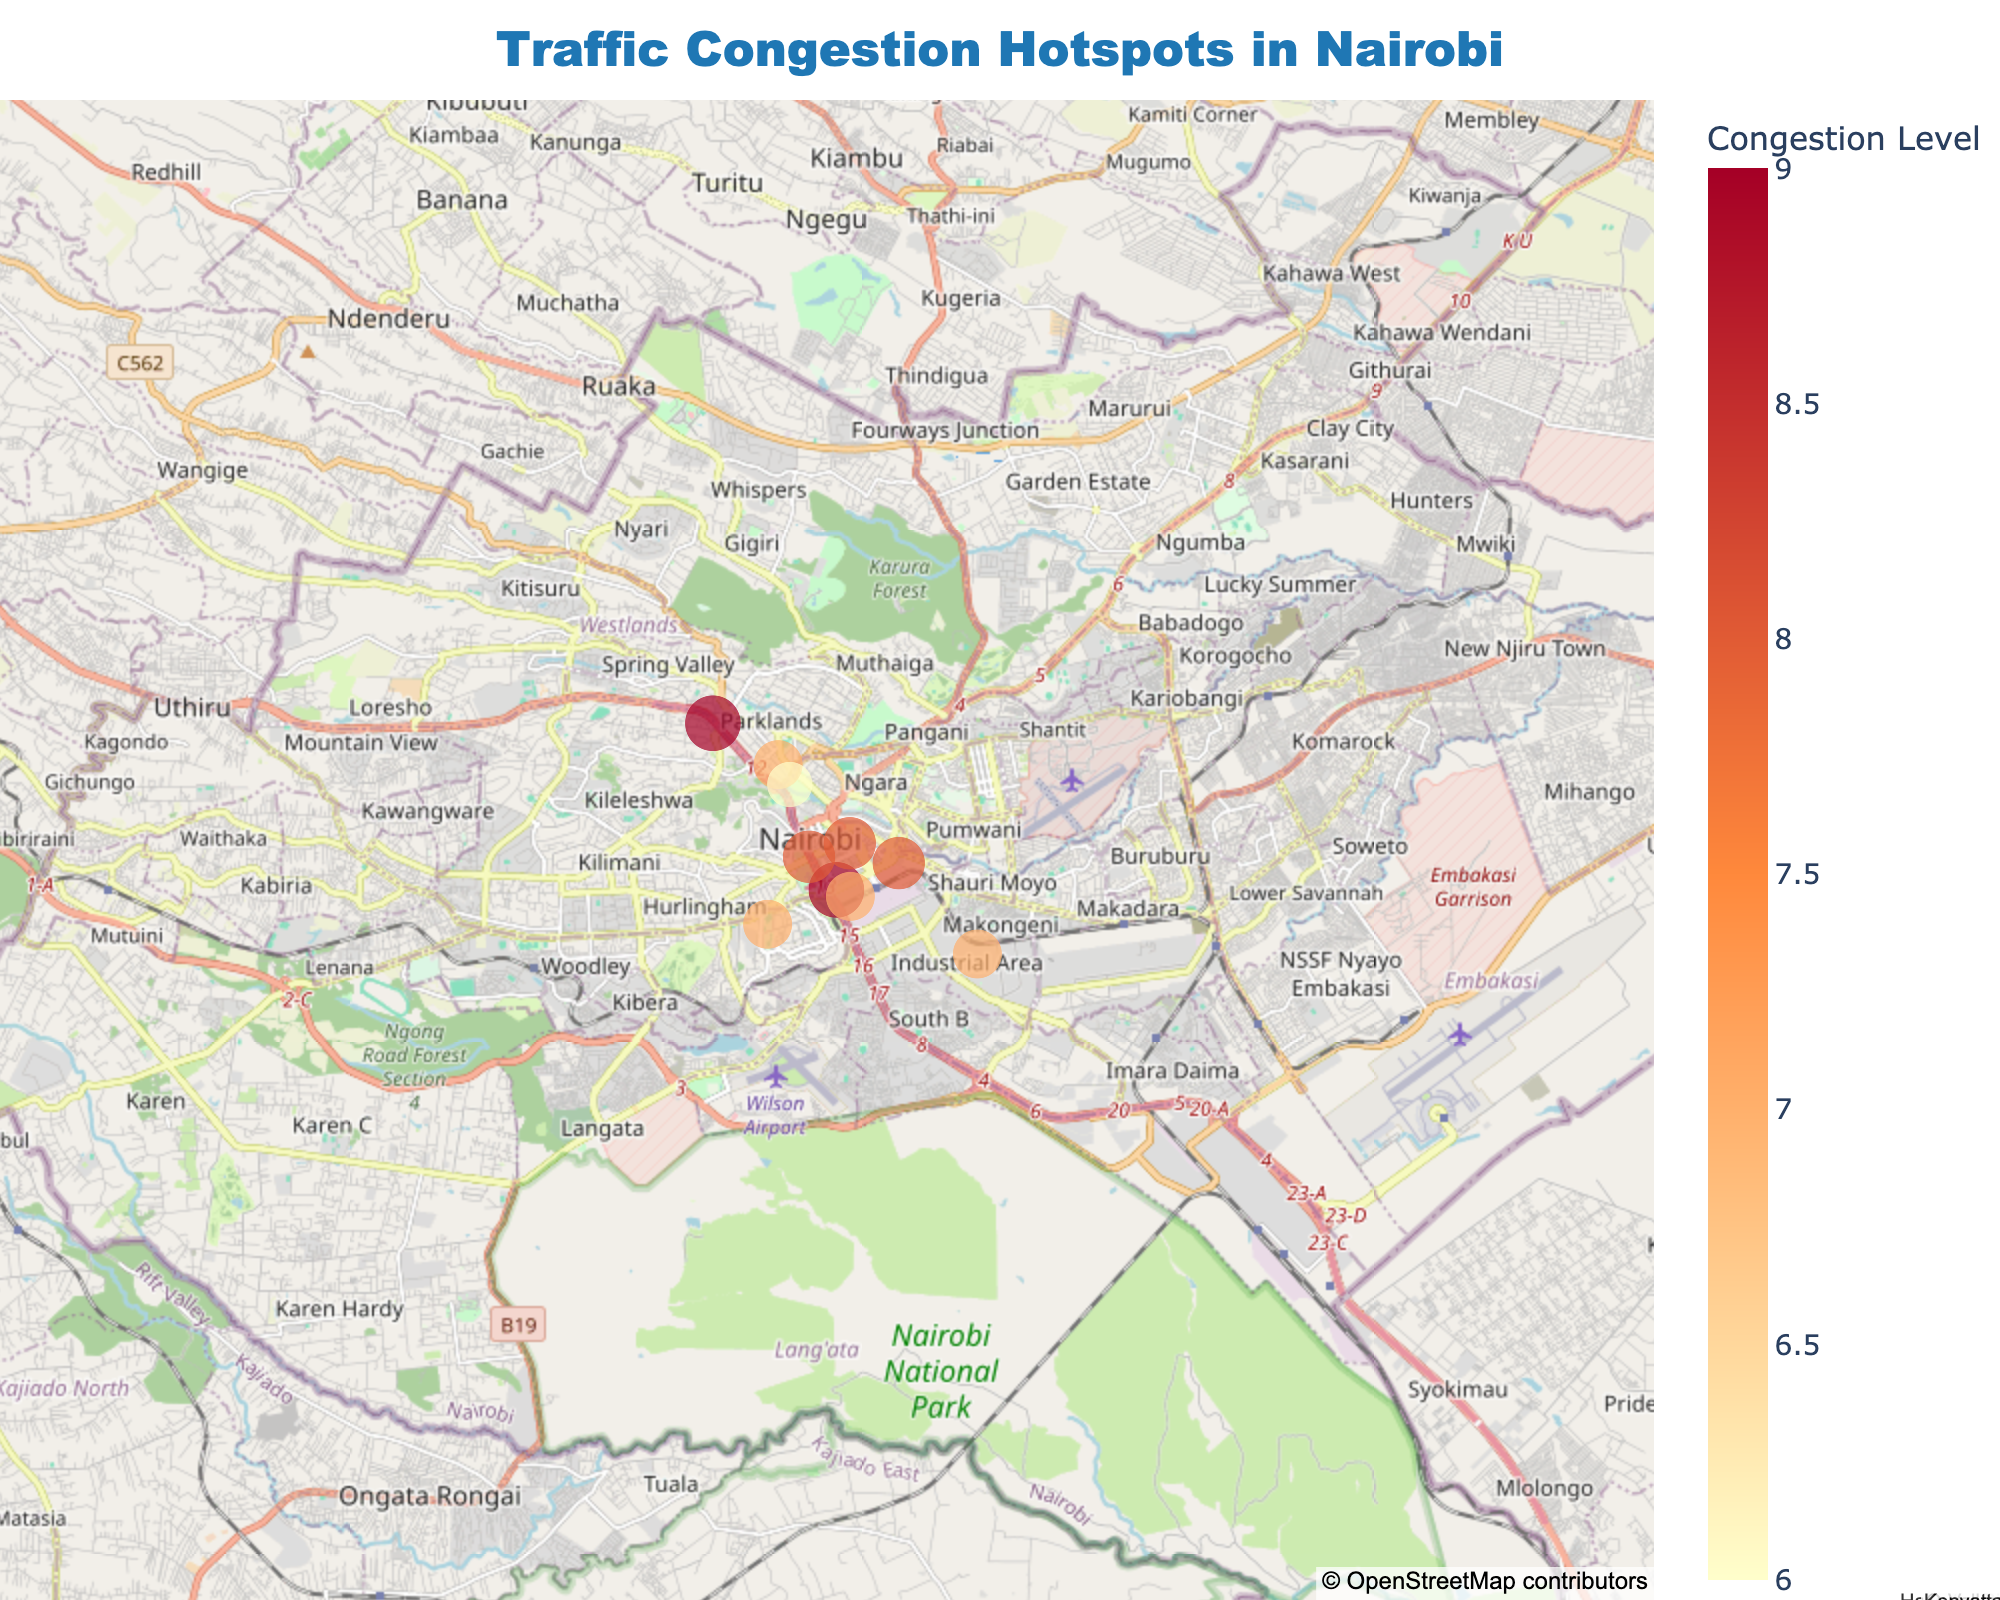How many major traffic congestion hotspots are marked on the map of Nairobi? Count the number of data points marked on the map to determine the number of major hotspots.
Answer: 10 Which major road has the highest congestion level, and what is its peak hours? Look for the data point with the highest congestion level and note its corresponding road and peak hours.
Answer: Uhuru Highway, 07:00-09:00; 17:00-19:00 Are there more congestion hotspots with a congestion level of 7 or 9? Count the number of data points with congestion levels 7 and 9 respectively and compare.
Answer: More with level 7 Between what hours is Langata Road most congested? Locate Langata Road on the map and refer its peak hours data from the hover info.
Answer: 07:30-09:30; 17:30-19:30 Which two roads have peak congestion starting the earliest and ending the latest, respectively? Identify the roads with the earliest start and latest end of peak hours by comparing the peak hours information of all roads.
Answer: Mombasa Road (earliest start), Jogoo Road (latest end) 